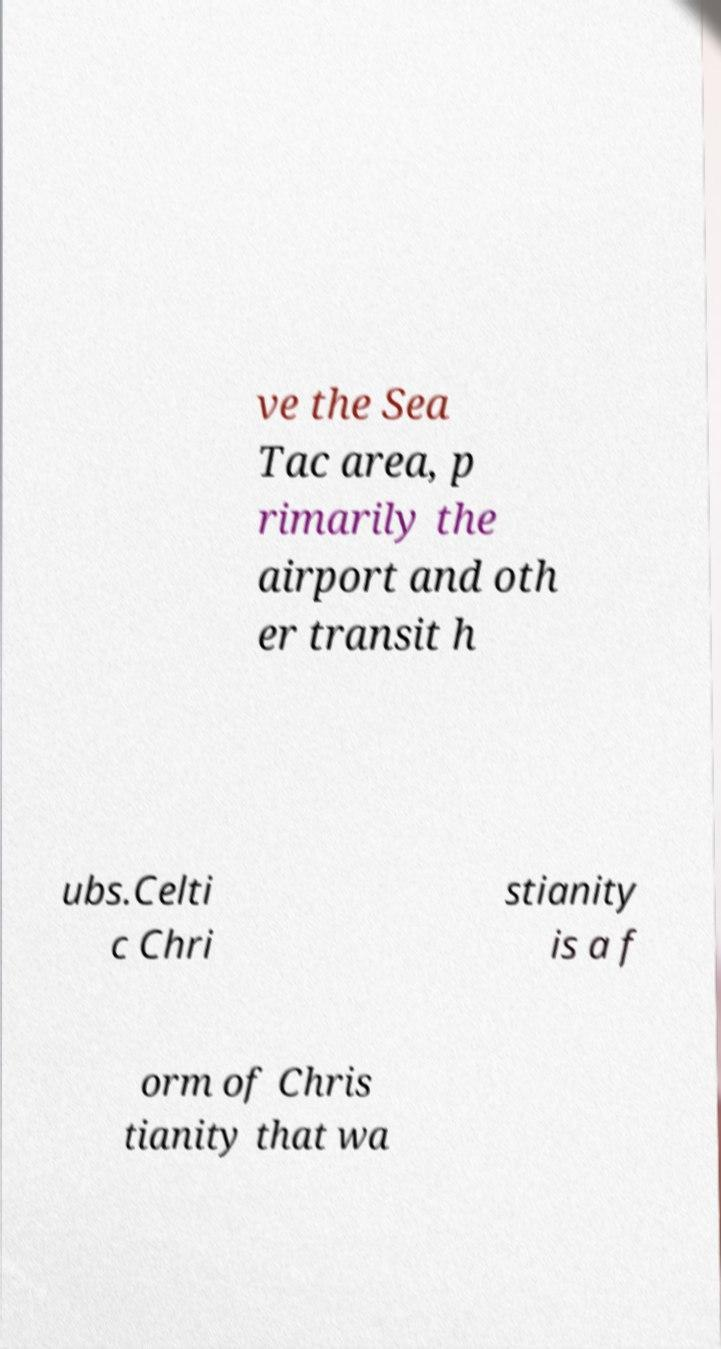Could you extract and type out the text from this image? ve the Sea Tac area, p rimarily the airport and oth er transit h ubs.Celti c Chri stianity is a f orm of Chris tianity that wa 